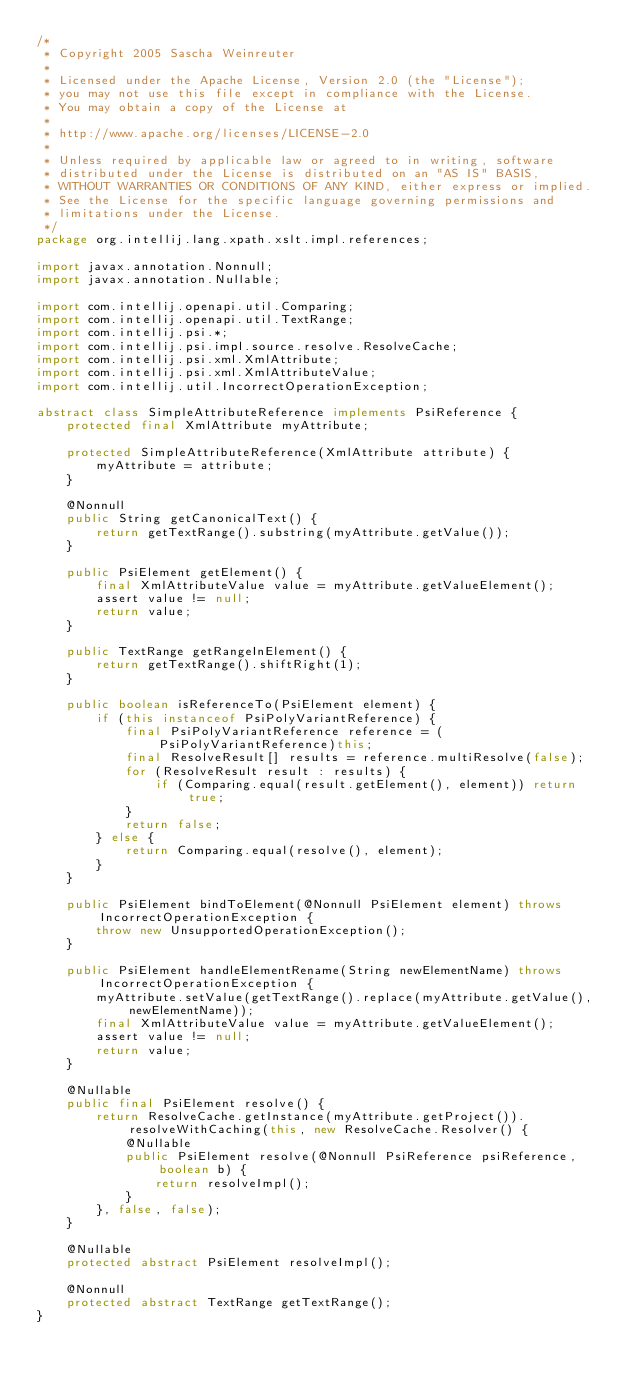<code> <loc_0><loc_0><loc_500><loc_500><_Java_>/*
 * Copyright 2005 Sascha Weinreuter
 *
 * Licensed under the Apache License, Version 2.0 (the "License");
 * you may not use this file except in compliance with the License.
 * You may obtain a copy of the License at
 *
 * http://www.apache.org/licenses/LICENSE-2.0
 *
 * Unless required by applicable law or agreed to in writing, software
 * distributed under the License is distributed on an "AS IS" BASIS,
 * WITHOUT WARRANTIES OR CONDITIONS OF ANY KIND, either express or implied.
 * See the License for the specific language governing permissions and
 * limitations under the License.
 */
package org.intellij.lang.xpath.xslt.impl.references;

import javax.annotation.Nonnull;
import javax.annotation.Nullable;

import com.intellij.openapi.util.Comparing;
import com.intellij.openapi.util.TextRange;
import com.intellij.psi.*;
import com.intellij.psi.impl.source.resolve.ResolveCache;
import com.intellij.psi.xml.XmlAttribute;
import com.intellij.psi.xml.XmlAttributeValue;
import com.intellij.util.IncorrectOperationException;

abstract class SimpleAttributeReference implements PsiReference {
    protected final XmlAttribute myAttribute;

    protected SimpleAttributeReference(XmlAttribute attribute) {
        myAttribute = attribute;
    }

    @Nonnull
    public String getCanonicalText() {
        return getTextRange().substring(myAttribute.getValue());
    }

    public PsiElement getElement() {
        final XmlAttributeValue value = myAttribute.getValueElement();
        assert value != null;
        return value;
    }

    public TextRange getRangeInElement() {
        return getTextRange().shiftRight(1);
    }

    public boolean isReferenceTo(PsiElement element) {
        if (this instanceof PsiPolyVariantReference) {
            final PsiPolyVariantReference reference = (PsiPolyVariantReference)this;
            final ResolveResult[] results = reference.multiResolve(false);
            for (ResolveResult result : results) {
                if (Comparing.equal(result.getElement(), element)) return true;
            }
            return false;
        } else {
            return Comparing.equal(resolve(), element);
        }
    }

    public PsiElement bindToElement(@Nonnull PsiElement element) throws IncorrectOperationException {
        throw new UnsupportedOperationException();
    }

    public PsiElement handleElementRename(String newElementName) throws IncorrectOperationException {
        myAttribute.setValue(getTextRange().replace(myAttribute.getValue(), newElementName));
        final XmlAttributeValue value = myAttribute.getValueElement();
        assert value != null;
        return value;
    }

    @Nullable
    public final PsiElement resolve() {
        return ResolveCache.getInstance(myAttribute.getProject()).resolveWithCaching(this, new ResolveCache.Resolver() {
            @Nullable
            public PsiElement resolve(@Nonnull PsiReference psiReference, boolean b) {
                return resolveImpl();
            }
        }, false, false);
    }

    @Nullable
    protected abstract PsiElement resolveImpl();

    @Nonnull
    protected abstract TextRange getTextRange();
}</code> 